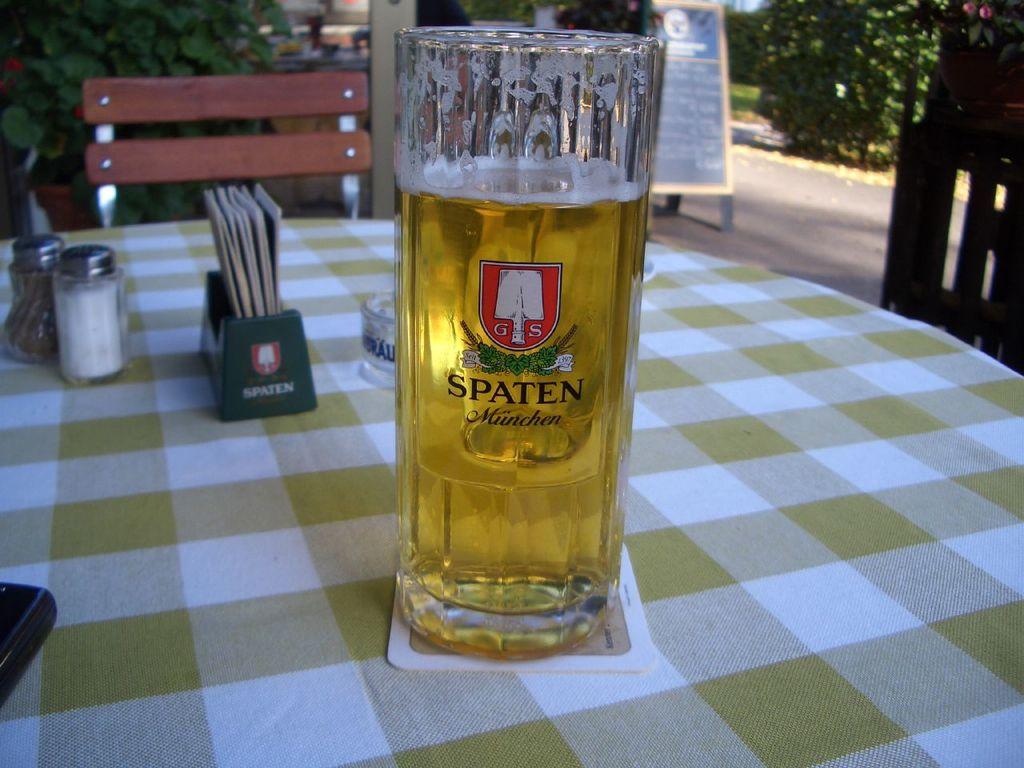What brand is on this mug?
Your answer should be very brief. Spaten. 